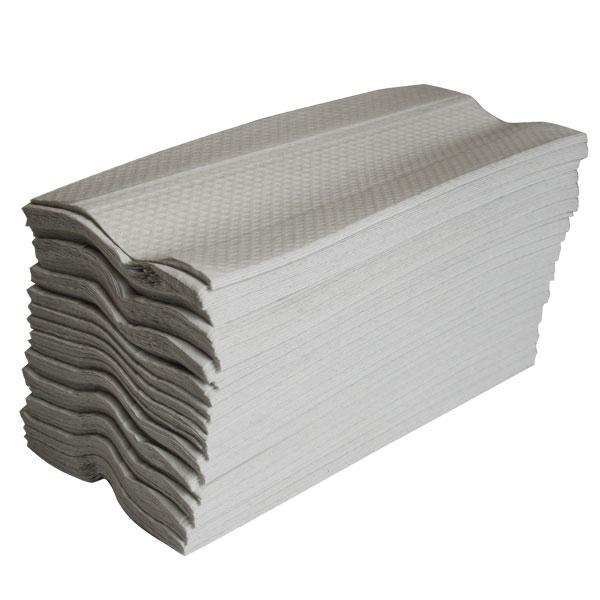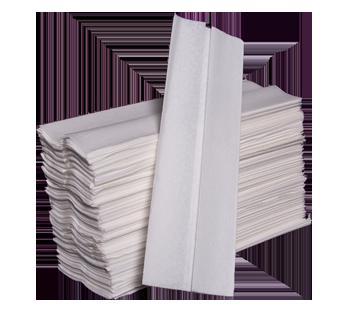The first image is the image on the left, the second image is the image on the right. Considering the images on both sides, is "One image shows a brown paper-wrapped bundle of folded paper towels with a few unwrapped towels in front of it, but no image includes a tall stack of unwrapped folded paper towels." valid? Answer yes or no. No. The first image is the image on the left, the second image is the image on the right. Assess this claim about the two images: "There is a least one stack of towels wrapped in brown paper". Correct or not? Answer yes or no. No. 